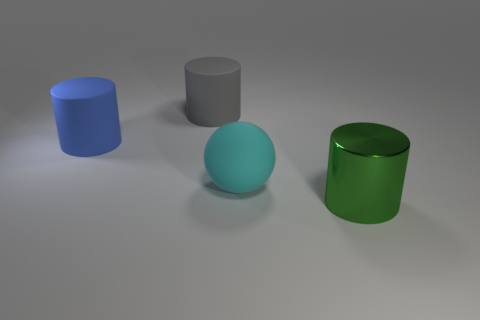Is there anything else that is made of the same material as the green thing?
Your response must be concise. No. What is the size of the rubber object to the left of the gray rubber cylinder?
Make the answer very short. Large. Do the matte ball and the large metallic thing have the same color?
Ensure brevity in your answer.  No. Is there any other thing that is the same shape as the blue rubber thing?
Offer a terse response. Yes. Are there the same number of blue rubber cylinders behind the big blue cylinder and gray matte cylinders?
Make the answer very short. No. Are there any big blue cylinders behind the green metallic cylinder?
Give a very brief answer. Yes. There is a green metallic thing; is it the same shape as the big object behind the large blue cylinder?
Your answer should be compact. Yes. What is the color of the big ball that is made of the same material as the large gray object?
Offer a very short reply. Cyan. What color is the big ball?
Your answer should be compact. Cyan. Are the ball and the object to the left of the large gray matte cylinder made of the same material?
Ensure brevity in your answer.  Yes. 